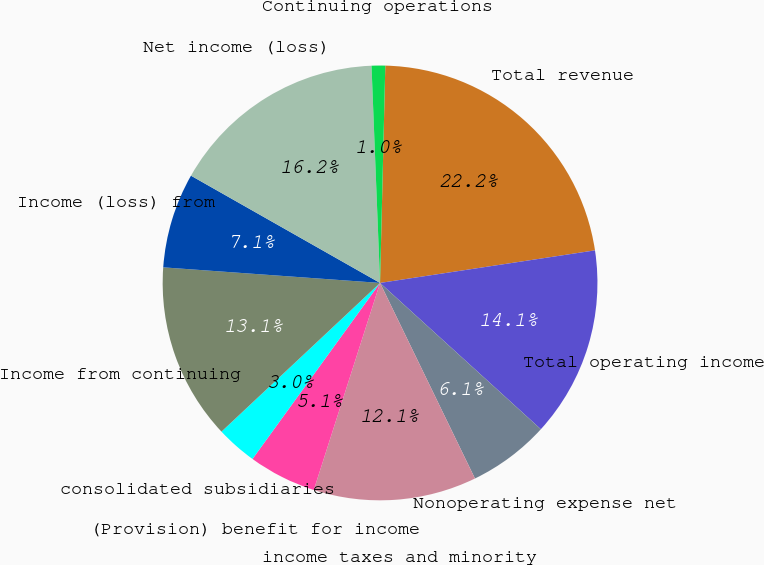Convert chart to OTSL. <chart><loc_0><loc_0><loc_500><loc_500><pie_chart><fcel>Total revenue<fcel>Total operating income<fcel>Nonoperating expense net<fcel>income taxes and minority<fcel>(Provision) benefit for income<fcel>consolidated subsidiaries<fcel>Income from continuing<fcel>Income (loss) from<fcel>Net income (loss)<fcel>Continuing operations<nl><fcel>22.22%<fcel>14.14%<fcel>6.06%<fcel>12.12%<fcel>5.05%<fcel>3.03%<fcel>13.13%<fcel>7.07%<fcel>16.16%<fcel>1.01%<nl></chart> 